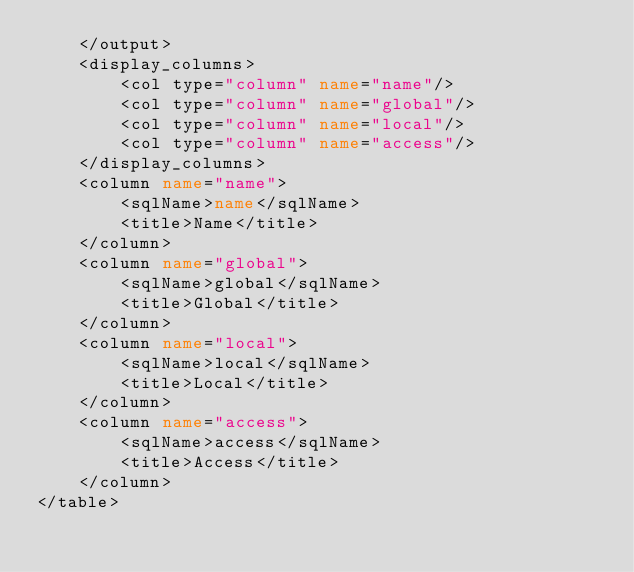<code> <loc_0><loc_0><loc_500><loc_500><_XML_>	</output>
	<display_columns>
		<col type="column" name="name"/>
		<col type="column" name="global"/>
		<col type="column" name="local"/>
		<col type="column" name="access"/>
	</display_columns>
	<column name="name">
		<sqlName>name</sqlName>
		<title>Name</title>
	</column>
	<column name="global">
		<sqlName>global</sqlName>
		<title>Global</title>
	</column>
	<column name="local">
		<sqlName>local</sqlName>
		<title>Local</title>
	</column>
	<column name="access">
		<sqlName>access</sqlName>
		<title>Access</title>
	</column>
</table>
</code> 